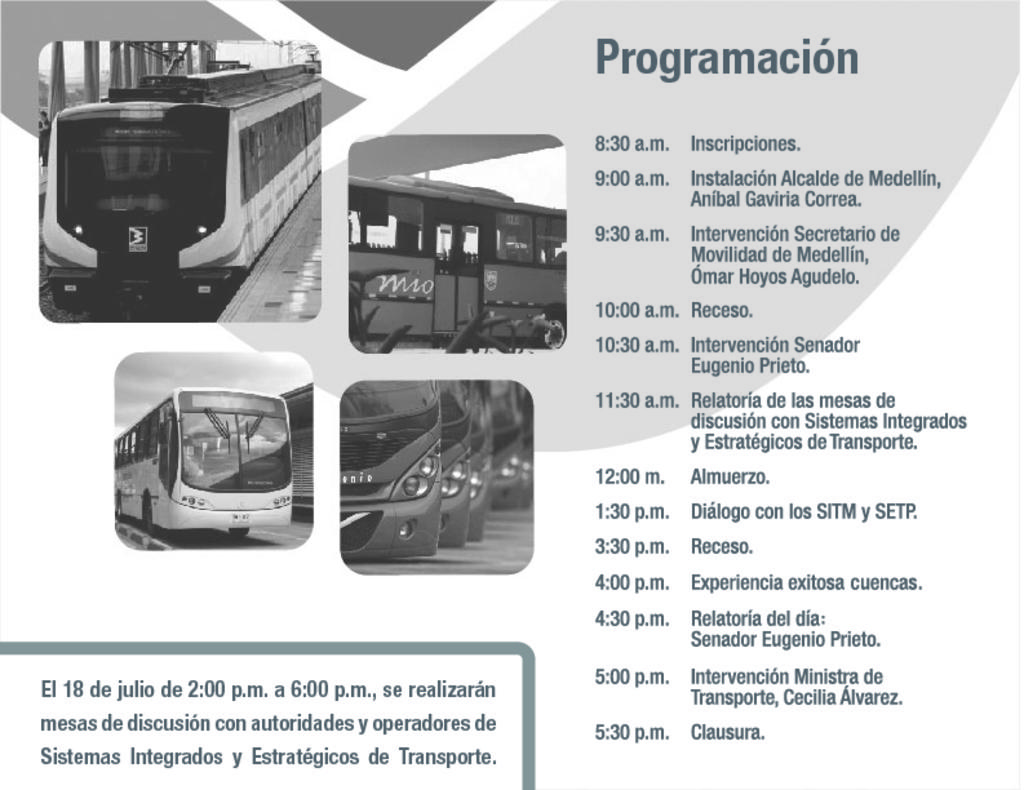What type of printed material is depicted in the image? The image appears to be a pamphlet. What modes of transportation are featured on the pamphlet? There are images of buses and a train on the pamphlet. Is there any text present on the pamphlet? Yes, there is text written on the pamphlet. Can you see a hook attached to the train in the image? There is no hook attached to the train in the image; only the train itself and the surrounding context are visible. 